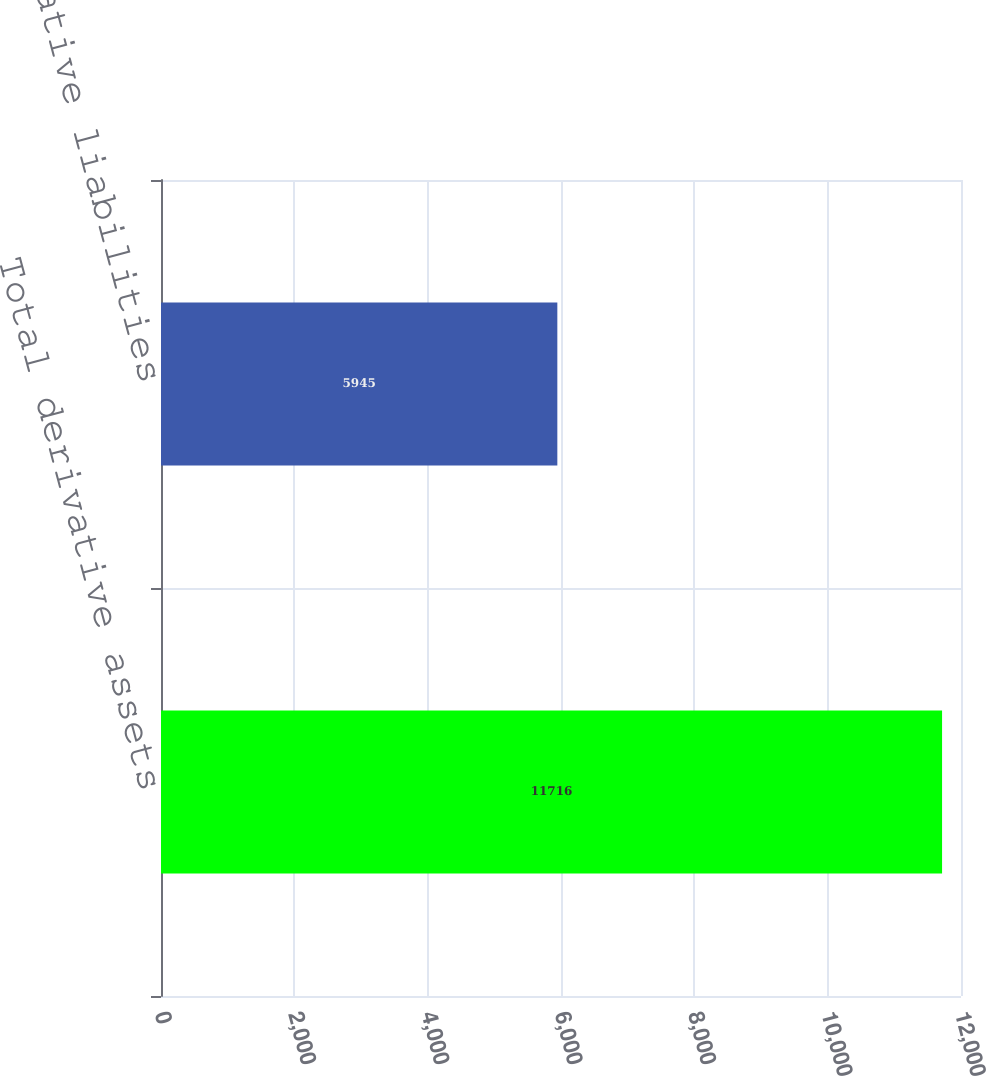<chart> <loc_0><loc_0><loc_500><loc_500><bar_chart><fcel>Total derivative assets<fcel>Total derivative liabilities<nl><fcel>11716<fcel>5945<nl></chart> 